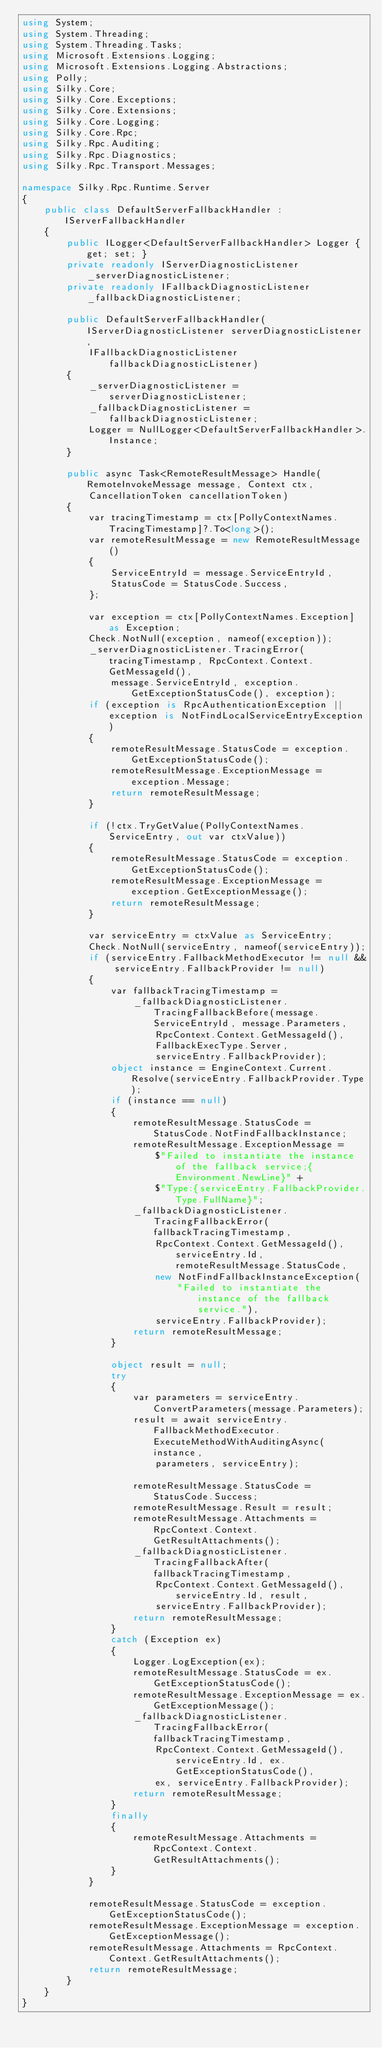Convert code to text. <code><loc_0><loc_0><loc_500><loc_500><_C#_>using System;
using System.Threading;
using System.Threading.Tasks;
using Microsoft.Extensions.Logging;
using Microsoft.Extensions.Logging.Abstractions;
using Polly;
using Silky.Core;
using Silky.Core.Exceptions;
using Silky.Core.Extensions;
using Silky.Core.Logging;
using Silky.Core.Rpc;
using Silky.Rpc.Auditing;
using Silky.Rpc.Diagnostics;
using Silky.Rpc.Transport.Messages;

namespace Silky.Rpc.Runtime.Server
{
    public class DefaultServerFallbackHandler : IServerFallbackHandler
    {
        public ILogger<DefaultServerFallbackHandler> Logger { get; set; }
        private readonly IServerDiagnosticListener _serverDiagnosticListener;
        private readonly IFallbackDiagnosticListener _fallbackDiagnosticListener;

        public DefaultServerFallbackHandler(IServerDiagnosticListener serverDiagnosticListener,
            IFallbackDiagnosticListener fallbackDiagnosticListener)
        {
            _serverDiagnosticListener = serverDiagnosticListener;
            _fallbackDiagnosticListener = fallbackDiagnosticListener;
            Logger = NullLogger<DefaultServerFallbackHandler>.Instance;
        }

        public async Task<RemoteResultMessage> Handle(RemoteInvokeMessage message, Context ctx,
            CancellationToken cancellationToken)
        {
            var tracingTimestamp = ctx[PollyContextNames.TracingTimestamp]?.To<long>();
            var remoteResultMessage = new RemoteResultMessage()
            {
                ServiceEntryId = message.ServiceEntryId,
                StatusCode = StatusCode.Success,
            };

            var exception = ctx[PollyContextNames.Exception] as Exception;
            Check.NotNull(exception, nameof(exception));
            _serverDiagnosticListener.TracingError(tracingTimestamp, RpcContext.Context.GetMessageId(),
                message.ServiceEntryId, exception.GetExceptionStatusCode(), exception);
            if (exception is RpcAuthenticationException || exception is NotFindLocalServiceEntryException)
            {
                remoteResultMessage.StatusCode = exception.GetExceptionStatusCode();
                remoteResultMessage.ExceptionMessage = exception.Message;
                return remoteResultMessage;
            }

            if (!ctx.TryGetValue(PollyContextNames.ServiceEntry, out var ctxValue))
            {
                remoteResultMessage.StatusCode = exception.GetExceptionStatusCode();
                remoteResultMessage.ExceptionMessage = exception.GetExceptionMessage();
                return remoteResultMessage;
            }

            var serviceEntry = ctxValue as ServiceEntry;
            Check.NotNull(serviceEntry, nameof(serviceEntry));
            if (serviceEntry.FallbackMethodExecutor != null && serviceEntry.FallbackProvider != null)
            {
                var fallbackTracingTimestamp =
                    _fallbackDiagnosticListener.TracingFallbackBefore(message.ServiceEntryId, message.Parameters,
                        RpcContext.Context.GetMessageId(),
                        FallbackExecType.Server,
                        serviceEntry.FallbackProvider);
                object instance = EngineContext.Current.Resolve(serviceEntry.FallbackProvider.Type);
                if (instance == null)
                {
                    remoteResultMessage.StatusCode = StatusCode.NotFindFallbackInstance;
                    remoteResultMessage.ExceptionMessage =
                        $"Failed to instantiate the instance of the fallback service;{Environment.NewLine}" +
                        $"Type:{serviceEntry.FallbackProvider.Type.FullName}";
                    _fallbackDiagnosticListener.TracingFallbackError(fallbackTracingTimestamp,
                        RpcContext.Context.GetMessageId(), serviceEntry.Id, remoteResultMessage.StatusCode,
                        new NotFindFallbackInstanceException(
                            "Failed to instantiate the instance of the fallback service."),
                        serviceEntry.FallbackProvider);
                    return remoteResultMessage;
                }

                object result = null;
                try
                {
                    var parameters = serviceEntry.ConvertParameters(message.Parameters);
                    result = await serviceEntry.FallbackMethodExecutor.ExecuteMethodWithAuditingAsync(instance,
                        parameters, serviceEntry);

                    remoteResultMessage.StatusCode = StatusCode.Success;
                    remoteResultMessage.Result = result;
                    remoteResultMessage.Attachments = RpcContext.Context.GetResultAttachments();
                    _fallbackDiagnosticListener.TracingFallbackAfter(fallbackTracingTimestamp,
                        RpcContext.Context.GetMessageId(), serviceEntry.Id, result,
                        serviceEntry.FallbackProvider);
                    return remoteResultMessage;
                }
                catch (Exception ex)
                {
                    Logger.LogException(ex);
                    remoteResultMessage.StatusCode = ex.GetExceptionStatusCode();
                    remoteResultMessage.ExceptionMessage = ex.GetExceptionMessage();
                    _fallbackDiagnosticListener.TracingFallbackError(fallbackTracingTimestamp,
                        RpcContext.Context.GetMessageId(), serviceEntry.Id, ex.GetExceptionStatusCode(),
                        ex, serviceEntry.FallbackProvider);
                    return remoteResultMessage;
                }
                finally
                {
                    remoteResultMessage.Attachments = RpcContext.Context.GetResultAttachments();
                }
            }

            remoteResultMessage.StatusCode = exception.GetExceptionStatusCode();
            remoteResultMessage.ExceptionMessage = exception.GetExceptionMessage();
            remoteResultMessage.Attachments = RpcContext.Context.GetResultAttachments();
            return remoteResultMessage;
        }
    }
}</code> 